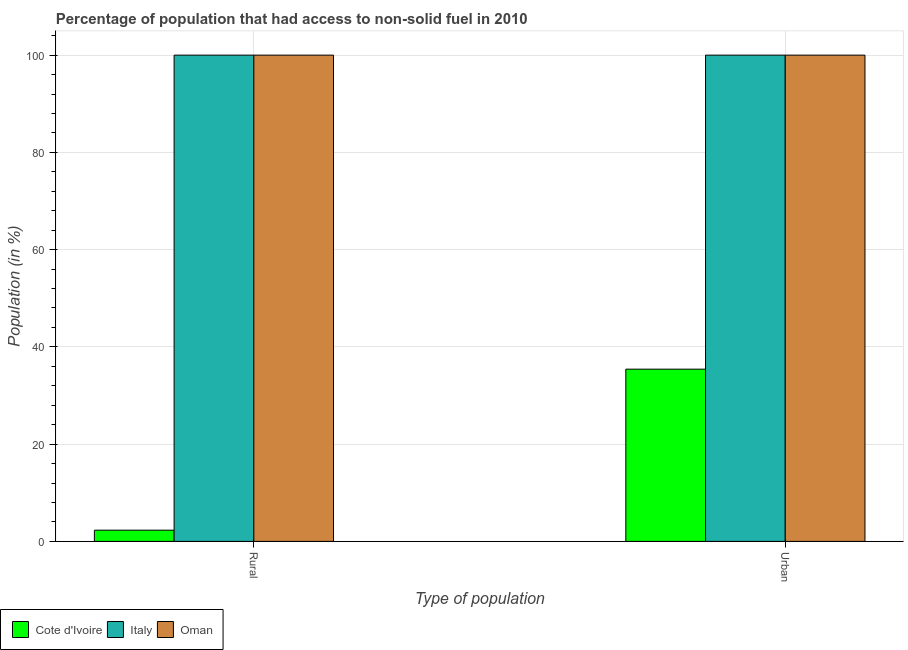How many groups of bars are there?
Offer a terse response. 2. Are the number of bars per tick equal to the number of legend labels?
Offer a terse response. Yes. Are the number of bars on each tick of the X-axis equal?
Make the answer very short. Yes. What is the label of the 2nd group of bars from the left?
Make the answer very short. Urban. What is the urban population in Italy?
Offer a terse response. 100. Across all countries, what is the maximum urban population?
Keep it short and to the point. 100. Across all countries, what is the minimum rural population?
Your response must be concise. 2.31. In which country was the rural population minimum?
Your answer should be compact. Cote d'Ivoire. What is the total urban population in the graph?
Make the answer very short. 235.42. What is the difference between the rural population in Cote d'Ivoire and that in Italy?
Your answer should be very brief. -97.69. What is the average urban population per country?
Your answer should be compact. 78.47. What is the difference between the urban population and rural population in Cote d'Ivoire?
Your response must be concise. 33.11. Is the urban population in Italy less than that in Oman?
Provide a succinct answer. No. In how many countries, is the rural population greater than the average rural population taken over all countries?
Provide a succinct answer. 2. What does the 1st bar from the right in Urban represents?
Provide a short and direct response. Oman. How many bars are there?
Give a very brief answer. 6. Are all the bars in the graph horizontal?
Your response must be concise. No. Are the values on the major ticks of Y-axis written in scientific E-notation?
Your answer should be compact. No. Does the graph contain any zero values?
Your answer should be compact. No. Where does the legend appear in the graph?
Your response must be concise. Bottom left. How many legend labels are there?
Provide a short and direct response. 3. How are the legend labels stacked?
Your response must be concise. Horizontal. What is the title of the graph?
Your answer should be very brief. Percentage of population that had access to non-solid fuel in 2010. What is the label or title of the X-axis?
Provide a succinct answer. Type of population. What is the Population (in %) of Cote d'Ivoire in Rural?
Provide a short and direct response. 2.31. What is the Population (in %) of Cote d'Ivoire in Urban?
Keep it short and to the point. 35.42. What is the Population (in %) in Italy in Urban?
Offer a very short reply. 100. Across all Type of population, what is the maximum Population (in %) of Cote d'Ivoire?
Your response must be concise. 35.42. Across all Type of population, what is the maximum Population (in %) of Italy?
Your answer should be very brief. 100. Across all Type of population, what is the minimum Population (in %) in Cote d'Ivoire?
Ensure brevity in your answer.  2.31. What is the total Population (in %) of Cote d'Ivoire in the graph?
Offer a terse response. 37.73. What is the difference between the Population (in %) of Cote d'Ivoire in Rural and that in Urban?
Keep it short and to the point. -33.11. What is the difference between the Population (in %) in Oman in Rural and that in Urban?
Provide a short and direct response. 0. What is the difference between the Population (in %) in Cote d'Ivoire in Rural and the Population (in %) in Italy in Urban?
Make the answer very short. -97.69. What is the difference between the Population (in %) of Cote d'Ivoire in Rural and the Population (in %) of Oman in Urban?
Make the answer very short. -97.69. What is the difference between the Population (in %) of Italy in Rural and the Population (in %) of Oman in Urban?
Offer a very short reply. 0. What is the average Population (in %) in Cote d'Ivoire per Type of population?
Offer a terse response. 18.86. What is the average Population (in %) of Oman per Type of population?
Provide a short and direct response. 100. What is the difference between the Population (in %) in Cote d'Ivoire and Population (in %) in Italy in Rural?
Keep it short and to the point. -97.69. What is the difference between the Population (in %) in Cote d'Ivoire and Population (in %) in Oman in Rural?
Your answer should be very brief. -97.69. What is the difference between the Population (in %) in Italy and Population (in %) in Oman in Rural?
Provide a short and direct response. 0. What is the difference between the Population (in %) in Cote d'Ivoire and Population (in %) in Italy in Urban?
Your response must be concise. -64.58. What is the difference between the Population (in %) in Cote d'Ivoire and Population (in %) in Oman in Urban?
Ensure brevity in your answer.  -64.58. What is the difference between the Population (in %) in Italy and Population (in %) in Oman in Urban?
Provide a short and direct response. 0. What is the ratio of the Population (in %) in Cote d'Ivoire in Rural to that in Urban?
Your answer should be very brief. 0.07. What is the ratio of the Population (in %) of Italy in Rural to that in Urban?
Keep it short and to the point. 1. What is the difference between the highest and the second highest Population (in %) of Cote d'Ivoire?
Give a very brief answer. 33.11. What is the difference between the highest and the lowest Population (in %) in Cote d'Ivoire?
Your response must be concise. 33.11. What is the difference between the highest and the lowest Population (in %) of Italy?
Give a very brief answer. 0. What is the difference between the highest and the lowest Population (in %) of Oman?
Offer a very short reply. 0. 